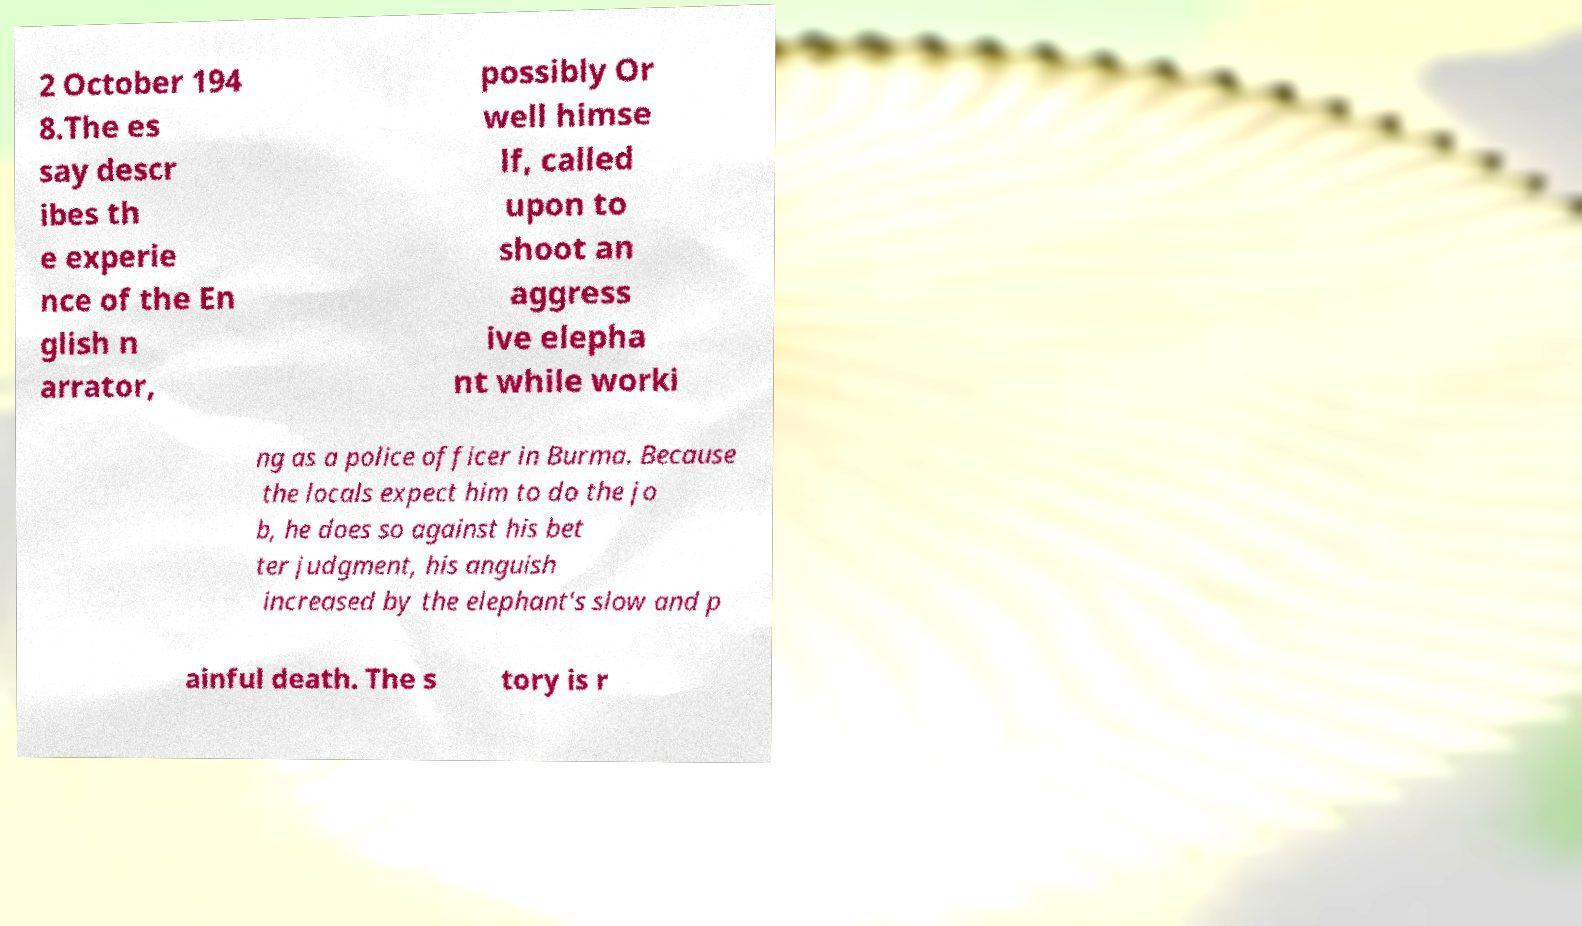Could you extract and type out the text from this image? 2 October 194 8.The es say descr ibes th e experie nce of the En glish n arrator, possibly Or well himse lf, called upon to shoot an aggress ive elepha nt while worki ng as a police officer in Burma. Because the locals expect him to do the jo b, he does so against his bet ter judgment, his anguish increased by the elephant's slow and p ainful death. The s tory is r 